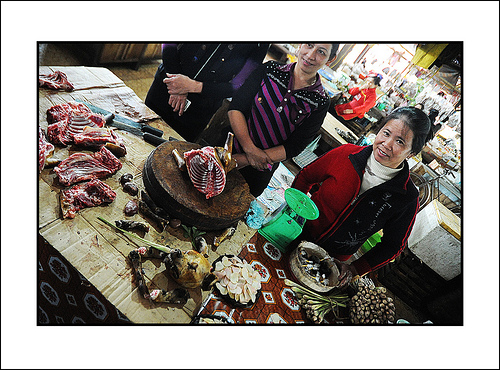<image>
Is there a scale under the shirt? No. The scale is not positioned under the shirt. The vertical relationship between these objects is different. 